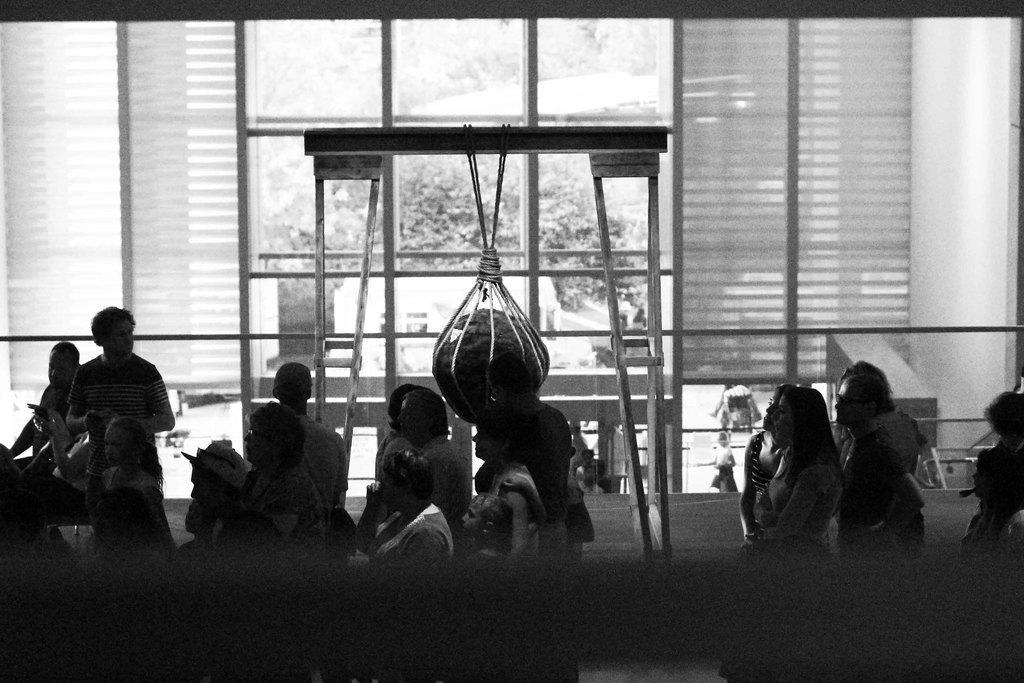Could you give a brief overview of what you see in this image? In this image I can see people are standing. In the background I can see trees and other objects. This picture is black and white in color. 